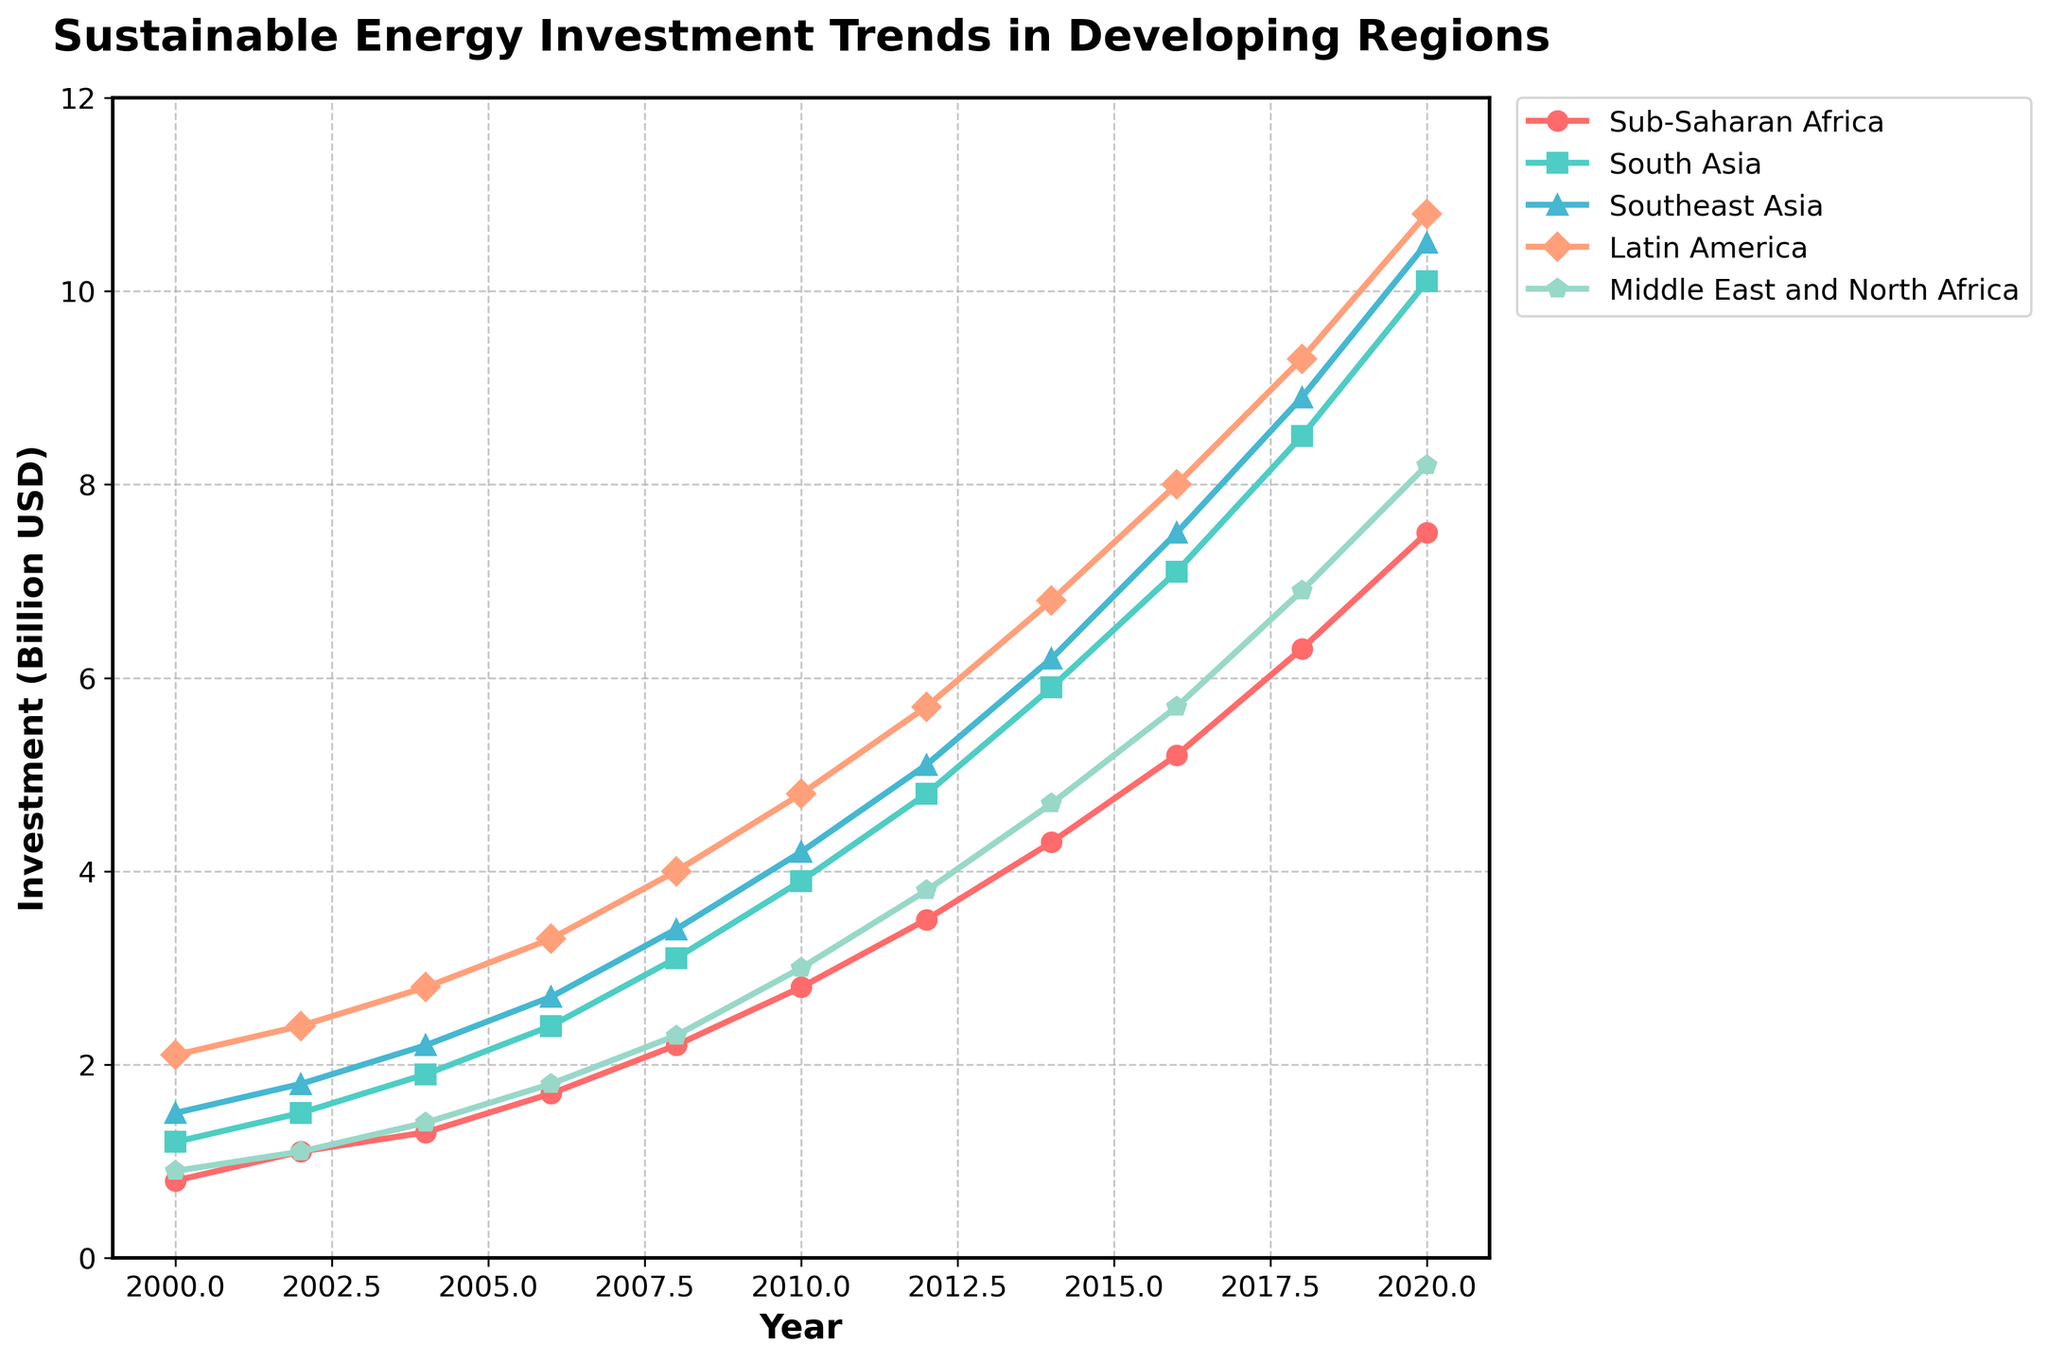Which region had the highest investment in the year 2020? Look at the data point for each region in the year 2020. South Asia had the highest investment at 10.1 billion USD, followed by Southeast Asia, Latin America, and others.
Answer: South Asia How much did investments in Sub-Saharan Africa grow from 2000 to 2020? Calculate the difference between the investment values in 2020 and 2000 for Sub-Saharan Africa: 7.5 billion USD in 2020 minus 0.8 billion USD in 2000 equals 6.7 billion USD.
Answer: 6.7 billion USD Which region had the least growth in investment over the two decades? Compare the increase in investments from 2000 to 2020 for each region. The Middle East and North Africa increased from 0.9 billion USD to 8.2 billion USD, which is an increase of 7.3 billion USD. Other regions had higher increases.
Answer: Middle East and North Africa In which year did South Asia's investment first exceed 4 billion USD? Observe the investment line for South Asia and identify the first year when the investment surpassed the 4 billion USD mark. This occurred in 2010.
Answer: 2010 By how much did the investment in Latin America exceed that of Southeast Asia in 2006? Find the investment values for Latin America and Southeast Asia in the year 2006. Latin America had 3.3 billion USD while Southeast Asia had 2.7 billion USD. The difference is 3.3 - 2.7 = 0.6 billion USD.
Answer: 0.6 billion USD Which two regions had nearly identical investments in 2000? Compare the investment values for the year 2000. Sub-Saharan Africa (0.8 billion USD) and Middle East and North Africa (0.9 billion USD) had nearly identical investments.
Answer: Sub-Saharan Africa and Middle East and North Africa What is the average investment in Southeast Asia over the period 2000 to 2020? Add all the investment values for Southeast Asia from 2000 to 2020 and divide by the number of years. (1.5+1.8+2.2+2.7+3.4+4.2+5.1+6.2+7.5+8.9+10.5)/11 = 54.0/11 ≈ 4.9 billion USD.
Answer: 4.9 billion USD When did Latin America's investment first exceed 5 billion USD? Trace the line representing Latin America and find the year when the investment first exceeds 5 billion USD. This happens in 2012.
Answer: 2012 Which region experienced the most consistent growth over the two decades? Evaluate the smoothness and consistent rise in the investment lines for each region. Sub-Saharan Africa's line shows a steady, linear increase throughout the period.
Answer: Sub-Saharan Africa By what factor did the investment in South Asia increase from 2008 to 2020? Divide the investment value in 2020 by the value in 2008 for South Asia. 10.1 billion USD in 2020 divided by 3.1 billion USD in 2008 equals approximately 3.26.
Answer: 3.26 